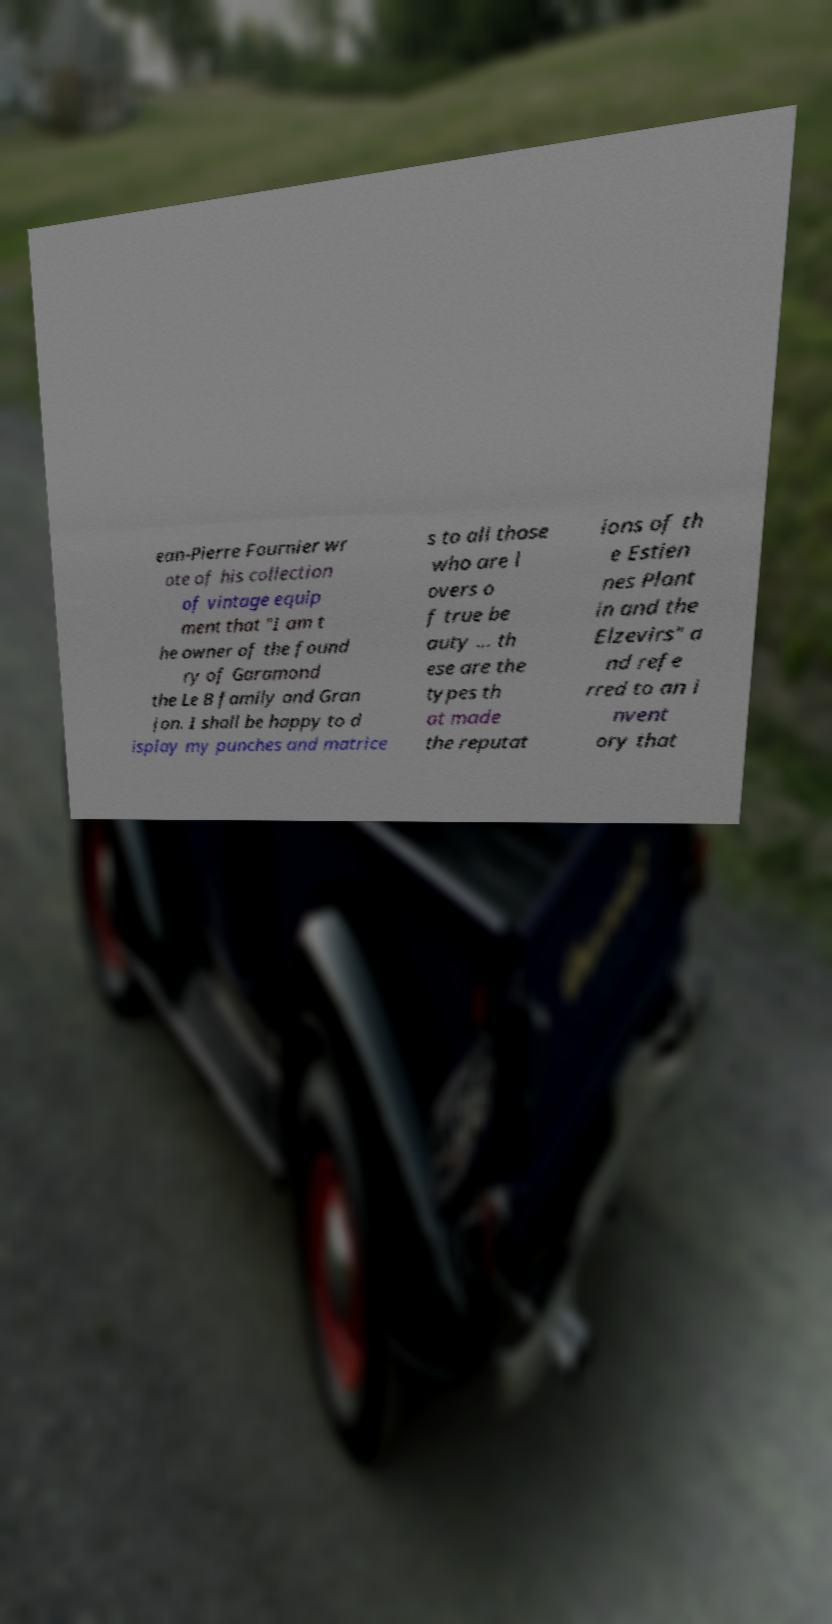Please read and relay the text visible in this image. What does it say? ean-Pierre Fournier wr ote of his collection of vintage equip ment that "I am t he owner of the found ry of Garamond the Le B family and Gran jon. I shall be happy to d isplay my punches and matrice s to all those who are l overs o f true be auty ... th ese are the types th at made the reputat ions of th e Estien nes Plant in and the Elzevirs" a nd refe rred to an i nvent ory that 